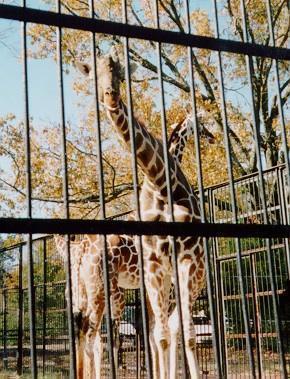What is between the is the fence made of?
Answer the question by selecting the correct answer among the 4 following choices.
Options: Steel, wood, glass, plastic. Steel. 